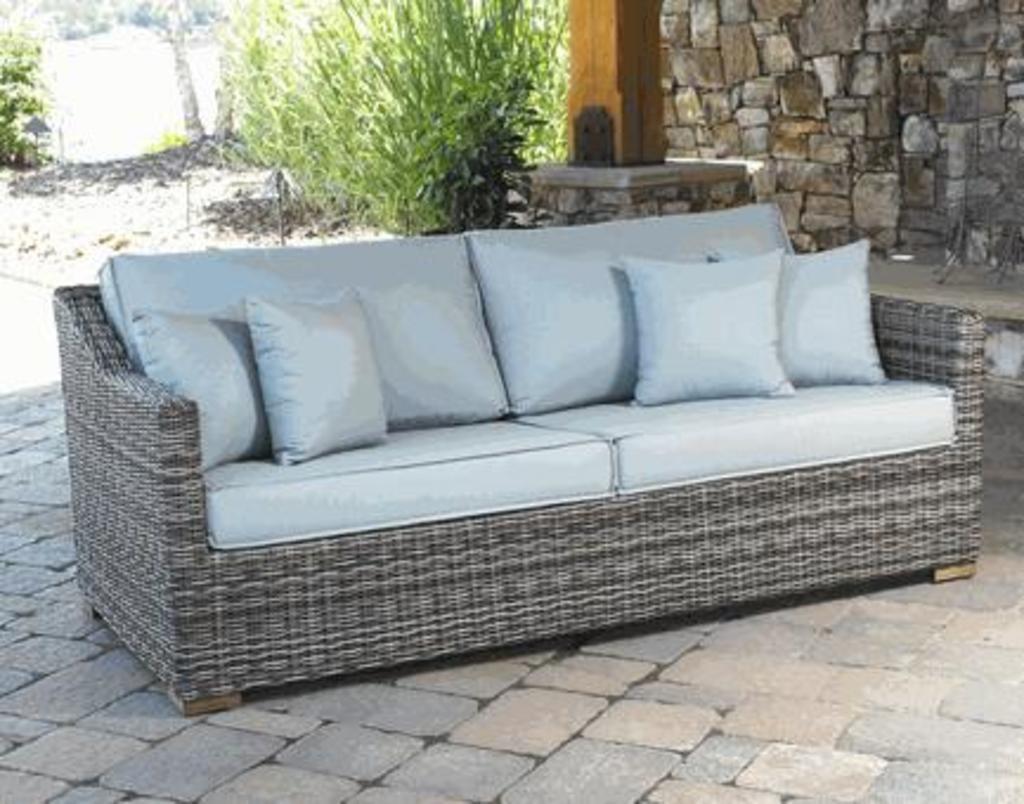Please provide a concise description of this image. In this image we can see a sofa with pillows. In the background we can see shrubs and stone wall. 